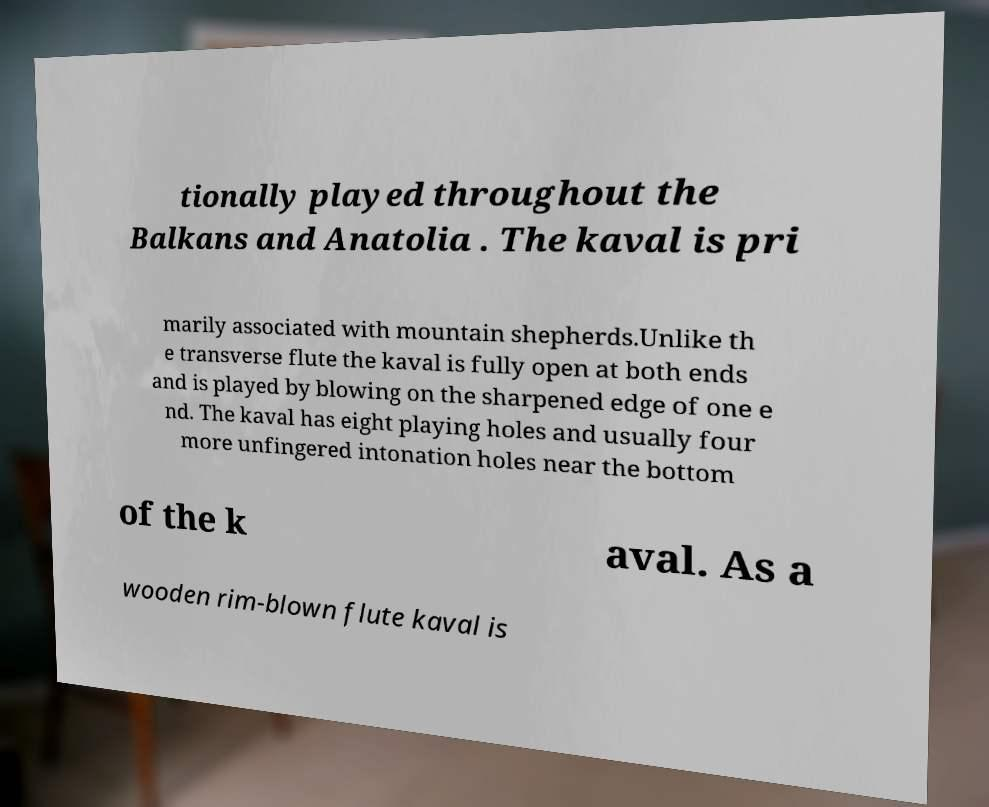Could you extract and type out the text from this image? tionally played throughout the Balkans and Anatolia . The kaval is pri marily associated with mountain shepherds.Unlike th e transverse flute the kaval is fully open at both ends and is played by blowing on the sharpened edge of one e nd. The kaval has eight playing holes and usually four more unfingered intonation holes near the bottom of the k aval. As a wooden rim-blown flute kaval is 